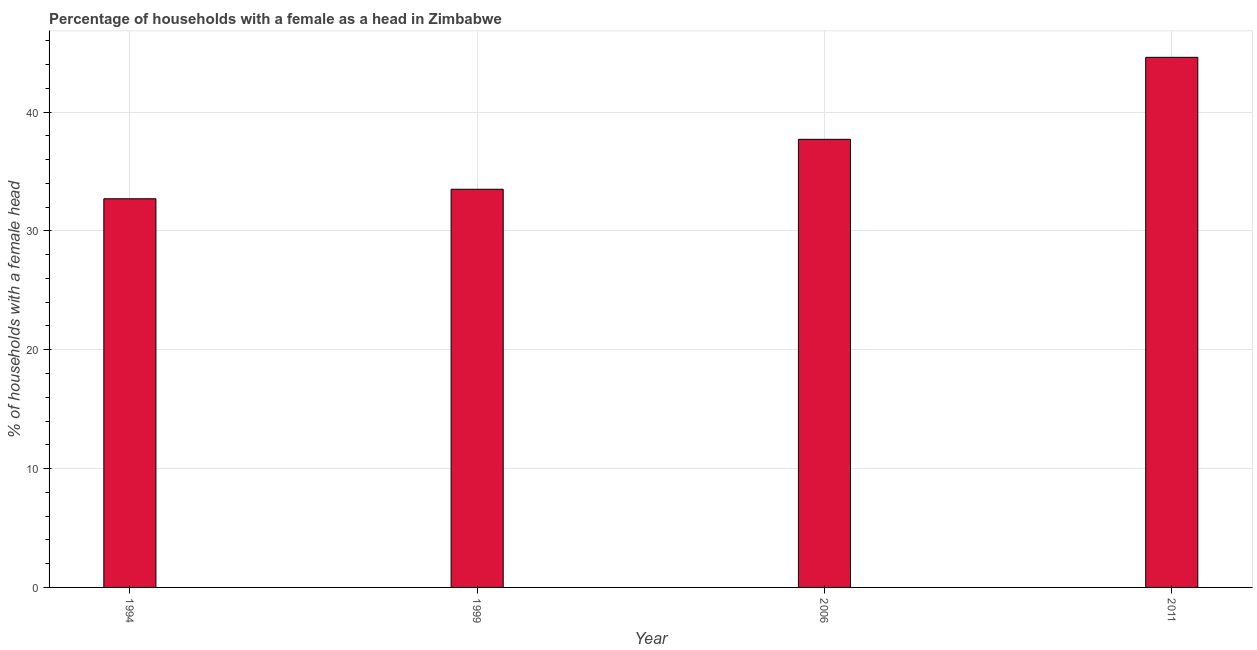Does the graph contain any zero values?
Give a very brief answer. No. Does the graph contain grids?
Make the answer very short. Yes. What is the title of the graph?
Your answer should be very brief. Percentage of households with a female as a head in Zimbabwe. What is the label or title of the Y-axis?
Offer a terse response. % of households with a female head. What is the number of female supervised households in 1999?
Keep it short and to the point. 33.5. Across all years, what is the maximum number of female supervised households?
Ensure brevity in your answer.  44.6. Across all years, what is the minimum number of female supervised households?
Offer a terse response. 32.7. What is the sum of the number of female supervised households?
Your answer should be very brief. 148.5. What is the average number of female supervised households per year?
Give a very brief answer. 37.12. What is the median number of female supervised households?
Your answer should be very brief. 35.6. In how many years, is the number of female supervised households greater than 6 %?
Give a very brief answer. 4. Do a majority of the years between 2011 and 1994 (inclusive) have number of female supervised households greater than 4 %?
Provide a succinct answer. Yes. What is the ratio of the number of female supervised households in 1994 to that in 2006?
Keep it short and to the point. 0.87. Is the difference between the number of female supervised households in 1994 and 2011 greater than the difference between any two years?
Make the answer very short. Yes. What is the difference between the highest and the second highest number of female supervised households?
Your answer should be very brief. 6.9. Is the sum of the number of female supervised households in 1999 and 2006 greater than the maximum number of female supervised households across all years?
Provide a short and direct response. Yes. What is the difference between the highest and the lowest number of female supervised households?
Your answer should be very brief. 11.9. In how many years, is the number of female supervised households greater than the average number of female supervised households taken over all years?
Offer a very short reply. 2. How many bars are there?
Ensure brevity in your answer.  4. Are all the bars in the graph horizontal?
Ensure brevity in your answer.  No. How many years are there in the graph?
Your answer should be very brief. 4. What is the % of households with a female head of 1994?
Offer a very short reply. 32.7. What is the % of households with a female head of 1999?
Your answer should be very brief. 33.5. What is the % of households with a female head of 2006?
Ensure brevity in your answer.  37.7. What is the % of households with a female head in 2011?
Give a very brief answer. 44.6. What is the difference between the % of households with a female head in 1999 and 2006?
Provide a succinct answer. -4.2. What is the difference between the % of households with a female head in 1999 and 2011?
Your answer should be compact. -11.1. What is the difference between the % of households with a female head in 2006 and 2011?
Offer a terse response. -6.9. What is the ratio of the % of households with a female head in 1994 to that in 1999?
Provide a succinct answer. 0.98. What is the ratio of the % of households with a female head in 1994 to that in 2006?
Provide a succinct answer. 0.87. What is the ratio of the % of households with a female head in 1994 to that in 2011?
Provide a succinct answer. 0.73. What is the ratio of the % of households with a female head in 1999 to that in 2006?
Offer a terse response. 0.89. What is the ratio of the % of households with a female head in 1999 to that in 2011?
Offer a very short reply. 0.75. What is the ratio of the % of households with a female head in 2006 to that in 2011?
Make the answer very short. 0.84. 